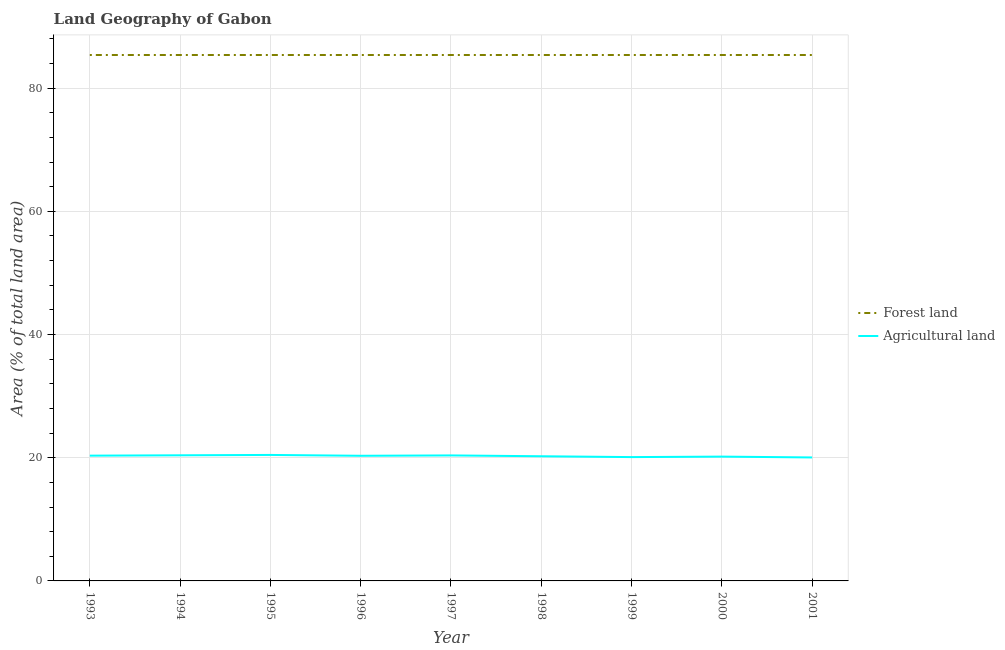Is the number of lines equal to the number of legend labels?
Give a very brief answer. Yes. What is the percentage of land area under forests in 1993?
Provide a succinct answer. 85.38. Across all years, what is the maximum percentage of land area under forests?
Your response must be concise. 85.38. Across all years, what is the minimum percentage of land area under forests?
Your response must be concise. 85.38. In which year was the percentage of land area under agriculture maximum?
Keep it short and to the point. 1995. In which year was the percentage of land area under forests minimum?
Offer a terse response. 1993. What is the total percentage of land area under agriculture in the graph?
Provide a succinct answer. 182.44. What is the difference between the percentage of land area under forests in 1995 and the percentage of land area under agriculture in 2001?
Your response must be concise. 65.34. What is the average percentage of land area under agriculture per year?
Make the answer very short. 20.27. In the year 1999, what is the difference between the percentage of land area under agriculture and percentage of land area under forests?
Offer a terse response. -65.28. What is the difference between the highest and the second highest percentage of land area under agriculture?
Ensure brevity in your answer.  0.06. What is the difference between the highest and the lowest percentage of land area under forests?
Provide a succinct answer. 0. In how many years, is the percentage of land area under agriculture greater than the average percentage of land area under agriculture taken over all years?
Your response must be concise. 5. Is the percentage of land area under agriculture strictly greater than the percentage of land area under forests over the years?
Give a very brief answer. No. What is the difference between two consecutive major ticks on the Y-axis?
Offer a very short reply. 20. Are the values on the major ticks of Y-axis written in scientific E-notation?
Provide a short and direct response. No. Does the graph contain any zero values?
Offer a terse response. No. Does the graph contain grids?
Keep it short and to the point. Yes. What is the title of the graph?
Your answer should be very brief. Land Geography of Gabon. What is the label or title of the Y-axis?
Keep it short and to the point. Area (% of total land area). What is the Area (% of total land area) of Forest land in 1993?
Your response must be concise. 85.38. What is the Area (% of total land area) of Agricultural land in 1993?
Your response must be concise. 20.34. What is the Area (% of total land area) of Forest land in 1994?
Your answer should be compact. 85.38. What is the Area (% of total land area) in Agricultural land in 1994?
Provide a short and direct response. 20.39. What is the Area (% of total land area) of Forest land in 1995?
Offer a terse response. 85.38. What is the Area (% of total land area) in Agricultural land in 1995?
Provide a short and direct response. 20.45. What is the Area (% of total land area) of Forest land in 1996?
Keep it short and to the point. 85.38. What is the Area (% of total land area) in Agricultural land in 1996?
Your answer should be very brief. 20.32. What is the Area (% of total land area) in Forest land in 1997?
Give a very brief answer. 85.38. What is the Area (% of total land area) of Agricultural land in 1997?
Your response must be concise. 20.37. What is the Area (% of total land area) of Forest land in 1998?
Provide a short and direct response. 85.38. What is the Area (% of total land area) in Agricultural land in 1998?
Your answer should be compact. 20.24. What is the Area (% of total land area) in Forest land in 1999?
Keep it short and to the point. 85.38. What is the Area (% of total land area) of Agricultural land in 1999?
Offer a very short reply. 20.1. What is the Area (% of total land area) of Forest land in 2000?
Keep it short and to the point. 85.38. What is the Area (% of total land area) in Agricultural land in 2000?
Your answer should be compact. 20.18. What is the Area (% of total land area) in Forest land in 2001?
Give a very brief answer. 85.38. What is the Area (% of total land area) of Agricultural land in 2001?
Give a very brief answer. 20.05. Across all years, what is the maximum Area (% of total land area) of Forest land?
Provide a succinct answer. 85.38. Across all years, what is the maximum Area (% of total land area) of Agricultural land?
Provide a succinct answer. 20.45. Across all years, what is the minimum Area (% of total land area) in Forest land?
Your answer should be very brief. 85.38. Across all years, what is the minimum Area (% of total land area) in Agricultural land?
Your response must be concise. 20.05. What is the total Area (% of total land area) of Forest land in the graph?
Your response must be concise. 768.42. What is the total Area (% of total land area) of Agricultural land in the graph?
Your answer should be compact. 182.44. What is the difference between the Area (% of total land area) in Forest land in 1993 and that in 1994?
Your response must be concise. 0. What is the difference between the Area (% of total land area) in Agricultural land in 1993 and that in 1994?
Provide a short and direct response. -0.06. What is the difference between the Area (% of total land area) of Forest land in 1993 and that in 1995?
Provide a short and direct response. 0. What is the difference between the Area (% of total land area) of Agricultural land in 1993 and that in 1995?
Your answer should be compact. -0.12. What is the difference between the Area (% of total land area) of Agricultural land in 1993 and that in 1996?
Offer a very short reply. 0.02. What is the difference between the Area (% of total land area) of Forest land in 1993 and that in 1997?
Keep it short and to the point. 0. What is the difference between the Area (% of total land area) in Agricultural land in 1993 and that in 1997?
Ensure brevity in your answer.  -0.04. What is the difference between the Area (% of total land area) of Agricultural land in 1993 and that in 1998?
Ensure brevity in your answer.  0.1. What is the difference between the Area (% of total land area) of Forest land in 1993 and that in 1999?
Offer a very short reply. 0. What is the difference between the Area (% of total land area) of Agricultural land in 1993 and that in 1999?
Your answer should be compact. 0.23. What is the difference between the Area (% of total land area) in Forest land in 1993 and that in 2000?
Offer a very short reply. 0. What is the difference between the Area (% of total land area) in Agricultural land in 1993 and that in 2000?
Make the answer very short. 0.16. What is the difference between the Area (% of total land area) of Forest land in 1993 and that in 2001?
Your answer should be compact. 0. What is the difference between the Area (% of total land area) in Agricultural land in 1993 and that in 2001?
Offer a terse response. 0.29. What is the difference between the Area (% of total land area) in Forest land in 1994 and that in 1995?
Provide a short and direct response. 0. What is the difference between the Area (% of total land area) in Agricultural land in 1994 and that in 1995?
Give a very brief answer. -0.06. What is the difference between the Area (% of total land area) of Agricultural land in 1994 and that in 1996?
Your response must be concise. 0.08. What is the difference between the Area (% of total land area) in Forest land in 1994 and that in 1997?
Make the answer very short. 0. What is the difference between the Area (% of total land area) of Agricultural land in 1994 and that in 1997?
Give a very brief answer. 0.02. What is the difference between the Area (% of total land area) of Agricultural land in 1994 and that in 1998?
Give a very brief answer. 0.16. What is the difference between the Area (% of total land area) of Agricultural land in 1994 and that in 1999?
Provide a succinct answer. 0.29. What is the difference between the Area (% of total land area) of Forest land in 1994 and that in 2000?
Make the answer very short. 0. What is the difference between the Area (% of total land area) in Agricultural land in 1994 and that in 2000?
Your response must be concise. 0.21. What is the difference between the Area (% of total land area) of Agricultural land in 1994 and that in 2001?
Offer a very short reply. 0.35. What is the difference between the Area (% of total land area) of Forest land in 1995 and that in 1996?
Your answer should be compact. 0. What is the difference between the Area (% of total land area) in Agricultural land in 1995 and that in 1996?
Keep it short and to the point. 0.14. What is the difference between the Area (% of total land area) in Forest land in 1995 and that in 1997?
Offer a very short reply. 0. What is the difference between the Area (% of total land area) in Agricultural land in 1995 and that in 1997?
Offer a very short reply. 0.08. What is the difference between the Area (% of total land area) in Agricultural land in 1995 and that in 1998?
Offer a very short reply. 0.21. What is the difference between the Area (% of total land area) of Forest land in 1995 and that in 1999?
Provide a short and direct response. 0. What is the difference between the Area (% of total land area) of Agricultural land in 1995 and that in 1999?
Your answer should be compact. 0.35. What is the difference between the Area (% of total land area) in Agricultural land in 1995 and that in 2000?
Your answer should be very brief. 0.27. What is the difference between the Area (% of total land area) in Agricultural land in 1995 and that in 2001?
Your answer should be very brief. 0.41. What is the difference between the Area (% of total land area) in Agricultural land in 1996 and that in 1997?
Offer a very short reply. -0.06. What is the difference between the Area (% of total land area) in Forest land in 1996 and that in 1998?
Keep it short and to the point. 0. What is the difference between the Area (% of total land area) in Agricultural land in 1996 and that in 1998?
Offer a terse response. 0.08. What is the difference between the Area (% of total land area) of Forest land in 1996 and that in 1999?
Provide a succinct answer. 0. What is the difference between the Area (% of total land area) in Agricultural land in 1996 and that in 1999?
Your answer should be compact. 0.21. What is the difference between the Area (% of total land area) of Forest land in 1996 and that in 2000?
Provide a succinct answer. 0. What is the difference between the Area (% of total land area) of Agricultural land in 1996 and that in 2000?
Keep it short and to the point. 0.14. What is the difference between the Area (% of total land area) in Agricultural land in 1996 and that in 2001?
Your answer should be compact. 0.27. What is the difference between the Area (% of total land area) in Agricultural land in 1997 and that in 1998?
Make the answer very short. 0.14. What is the difference between the Area (% of total land area) in Forest land in 1997 and that in 1999?
Keep it short and to the point. 0. What is the difference between the Area (% of total land area) in Agricultural land in 1997 and that in 1999?
Your answer should be very brief. 0.27. What is the difference between the Area (% of total land area) of Agricultural land in 1997 and that in 2000?
Your response must be concise. 0.19. What is the difference between the Area (% of total land area) in Agricultural land in 1997 and that in 2001?
Offer a terse response. 0.33. What is the difference between the Area (% of total land area) in Agricultural land in 1998 and that in 1999?
Give a very brief answer. 0.14. What is the difference between the Area (% of total land area) of Forest land in 1998 and that in 2000?
Your answer should be very brief. 0. What is the difference between the Area (% of total land area) in Agricultural land in 1998 and that in 2000?
Provide a succinct answer. 0.06. What is the difference between the Area (% of total land area) of Forest land in 1998 and that in 2001?
Make the answer very short. 0. What is the difference between the Area (% of total land area) in Agricultural land in 1998 and that in 2001?
Ensure brevity in your answer.  0.19. What is the difference between the Area (% of total land area) in Forest land in 1999 and that in 2000?
Make the answer very short. 0. What is the difference between the Area (% of total land area) in Agricultural land in 1999 and that in 2000?
Give a very brief answer. -0.08. What is the difference between the Area (% of total land area) in Forest land in 1999 and that in 2001?
Your answer should be compact. 0. What is the difference between the Area (% of total land area) of Agricultural land in 1999 and that in 2001?
Your response must be concise. 0.06. What is the difference between the Area (% of total land area) in Agricultural land in 2000 and that in 2001?
Your answer should be very brief. 0.14. What is the difference between the Area (% of total land area) in Forest land in 1993 and the Area (% of total land area) in Agricultural land in 1994?
Ensure brevity in your answer.  64.99. What is the difference between the Area (% of total land area) in Forest land in 1993 and the Area (% of total land area) in Agricultural land in 1995?
Your response must be concise. 64.93. What is the difference between the Area (% of total land area) of Forest land in 1993 and the Area (% of total land area) of Agricultural land in 1996?
Your answer should be compact. 65.06. What is the difference between the Area (% of total land area) of Forest land in 1993 and the Area (% of total land area) of Agricultural land in 1997?
Your answer should be very brief. 65.01. What is the difference between the Area (% of total land area) of Forest land in 1993 and the Area (% of total land area) of Agricultural land in 1998?
Ensure brevity in your answer.  65.14. What is the difference between the Area (% of total land area) in Forest land in 1993 and the Area (% of total land area) in Agricultural land in 1999?
Offer a very short reply. 65.28. What is the difference between the Area (% of total land area) of Forest land in 1993 and the Area (% of total land area) of Agricultural land in 2000?
Keep it short and to the point. 65.2. What is the difference between the Area (% of total land area) of Forest land in 1993 and the Area (% of total land area) of Agricultural land in 2001?
Your response must be concise. 65.34. What is the difference between the Area (% of total land area) in Forest land in 1994 and the Area (% of total land area) in Agricultural land in 1995?
Your response must be concise. 64.93. What is the difference between the Area (% of total land area) of Forest land in 1994 and the Area (% of total land area) of Agricultural land in 1996?
Your answer should be compact. 65.06. What is the difference between the Area (% of total land area) of Forest land in 1994 and the Area (% of total land area) of Agricultural land in 1997?
Offer a very short reply. 65.01. What is the difference between the Area (% of total land area) of Forest land in 1994 and the Area (% of total land area) of Agricultural land in 1998?
Your answer should be compact. 65.14. What is the difference between the Area (% of total land area) of Forest land in 1994 and the Area (% of total land area) of Agricultural land in 1999?
Provide a succinct answer. 65.28. What is the difference between the Area (% of total land area) of Forest land in 1994 and the Area (% of total land area) of Agricultural land in 2000?
Your response must be concise. 65.2. What is the difference between the Area (% of total land area) in Forest land in 1994 and the Area (% of total land area) in Agricultural land in 2001?
Keep it short and to the point. 65.34. What is the difference between the Area (% of total land area) of Forest land in 1995 and the Area (% of total land area) of Agricultural land in 1996?
Give a very brief answer. 65.06. What is the difference between the Area (% of total land area) in Forest land in 1995 and the Area (% of total land area) in Agricultural land in 1997?
Your answer should be compact. 65.01. What is the difference between the Area (% of total land area) of Forest land in 1995 and the Area (% of total land area) of Agricultural land in 1998?
Keep it short and to the point. 65.14. What is the difference between the Area (% of total land area) of Forest land in 1995 and the Area (% of total land area) of Agricultural land in 1999?
Your answer should be compact. 65.28. What is the difference between the Area (% of total land area) of Forest land in 1995 and the Area (% of total land area) of Agricultural land in 2000?
Give a very brief answer. 65.2. What is the difference between the Area (% of total land area) in Forest land in 1995 and the Area (% of total land area) in Agricultural land in 2001?
Ensure brevity in your answer.  65.34. What is the difference between the Area (% of total land area) in Forest land in 1996 and the Area (% of total land area) in Agricultural land in 1997?
Provide a short and direct response. 65.01. What is the difference between the Area (% of total land area) of Forest land in 1996 and the Area (% of total land area) of Agricultural land in 1998?
Offer a terse response. 65.14. What is the difference between the Area (% of total land area) in Forest land in 1996 and the Area (% of total land area) in Agricultural land in 1999?
Your answer should be compact. 65.28. What is the difference between the Area (% of total land area) of Forest land in 1996 and the Area (% of total land area) of Agricultural land in 2000?
Your answer should be very brief. 65.2. What is the difference between the Area (% of total land area) of Forest land in 1996 and the Area (% of total land area) of Agricultural land in 2001?
Your answer should be compact. 65.34. What is the difference between the Area (% of total land area) in Forest land in 1997 and the Area (% of total land area) in Agricultural land in 1998?
Provide a short and direct response. 65.14. What is the difference between the Area (% of total land area) in Forest land in 1997 and the Area (% of total land area) in Agricultural land in 1999?
Give a very brief answer. 65.28. What is the difference between the Area (% of total land area) of Forest land in 1997 and the Area (% of total land area) of Agricultural land in 2000?
Ensure brevity in your answer.  65.2. What is the difference between the Area (% of total land area) of Forest land in 1997 and the Area (% of total land area) of Agricultural land in 2001?
Your response must be concise. 65.34. What is the difference between the Area (% of total land area) in Forest land in 1998 and the Area (% of total land area) in Agricultural land in 1999?
Provide a short and direct response. 65.28. What is the difference between the Area (% of total land area) in Forest land in 1998 and the Area (% of total land area) in Agricultural land in 2000?
Offer a very short reply. 65.2. What is the difference between the Area (% of total land area) in Forest land in 1998 and the Area (% of total land area) in Agricultural land in 2001?
Offer a very short reply. 65.34. What is the difference between the Area (% of total land area) in Forest land in 1999 and the Area (% of total land area) in Agricultural land in 2000?
Keep it short and to the point. 65.2. What is the difference between the Area (% of total land area) of Forest land in 1999 and the Area (% of total land area) of Agricultural land in 2001?
Keep it short and to the point. 65.34. What is the difference between the Area (% of total land area) in Forest land in 2000 and the Area (% of total land area) in Agricultural land in 2001?
Your answer should be compact. 65.34. What is the average Area (% of total land area) of Forest land per year?
Offer a very short reply. 85.38. What is the average Area (% of total land area) in Agricultural land per year?
Make the answer very short. 20.27. In the year 1993, what is the difference between the Area (% of total land area) in Forest land and Area (% of total land area) in Agricultural land?
Offer a terse response. 65.04. In the year 1994, what is the difference between the Area (% of total land area) of Forest land and Area (% of total land area) of Agricultural land?
Your answer should be compact. 64.99. In the year 1995, what is the difference between the Area (% of total land area) in Forest land and Area (% of total land area) in Agricultural land?
Keep it short and to the point. 64.93. In the year 1996, what is the difference between the Area (% of total land area) in Forest land and Area (% of total land area) in Agricultural land?
Provide a succinct answer. 65.06. In the year 1997, what is the difference between the Area (% of total land area) in Forest land and Area (% of total land area) in Agricultural land?
Give a very brief answer. 65.01. In the year 1998, what is the difference between the Area (% of total land area) in Forest land and Area (% of total land area) in Agricultural land?
Keep it short and to the point. 65.14. In the year 1999, what is the difference between the Area (% of total land area) in Forest land and Area (% of total land area) in Agricultural land?
Your answer should be compact. 65.28. In the year 2000, what is the difference between the Area (% of total land area) in Forest land and Area (% of total land area) in Agricultural land?
Make the answer very short. 65.2. In the year 2001, what is the difference between the Area (% of total land area) in Forest land and Area (% of total land area) in Agricultural land?
Your answer should be very brief. 65.34. What is the ratio of the Area (% of total land area) in Forest land in 1993 to that in 1994?
Give a very brief answer. 1. What is the ratio of the Area (% of total land area) in Forest land in 1993 to that in 1995?
Provide a succinct answer. 1. What is the ratio of the Area (% of total land area) in Agricultural land in 1993 to that in 1995?
Provide a short and direct response. 0.99. What is the ratio of the Area (% of total land area) of Forest land in 1993 to that in 1996?
Keep it short and to the point. 1. What is the ratio of the Area (% of total land area) of Forest land in 1993 to that in 1997?
Give a very brief answer. 1. What is the ratio of the Area (% of total land area) in Agricultural land in 1993 to that in 1998?
Make the answer very short. 1. What is the ratio of the Area (% of total land area) in Forest land in 1993 to that in 1999?
Ensure brevity in your answer.  1. What is the ratio of the Area (% of total land area) of Agricultural land in 1993 to that in 1999?
Offer a terse response. 1.01. What is the ratio of the Area (% of total land area) of Agricultural land in 1993 to that in 2000?
Give a very brief answer. 1.01. What is the ratio of the Area (% of total land area) of Forest land in 1993 to that in 2001?
Provide a short and direct response. 1. What is the ratio of the Area (% of total land area) of Agricultural land in 1993 to that in 2001?
Ensure brevity in your answer.  1.01. What is the ratio of the Area (% of total land area) in Agricultural land in 1994 to that in 1995?
Your response must be concise. 1. What is the ratio of the Area (% of total land area) in Forest land in 1994 to that in 1997?
Provide a succinct answer. 1. What is the ratio of the Area (% of total land area) in Agricultural land in 1994 to that in 1997?
Your response must be concise. 1. What is the ratio of the Area (% of total land area) of Agricultural land in 1994 to that in 1998?
Provide a short and direct response. 1.01. What is the ratio of the Area (% of total land area) in Agricultural land in 1994 to that in 1999?
Offer a terse response. 1.01. What is the ratio of the Area (% of total land area) of Agricultural land in 1994 to that in 2000?
Your answer should be very brief. 1.01. What is the ratio of the Area (% of total land area) of Forest land in 1994 to that in 2001?
Offer a terse response. 1. What is the ratio of the Area (% of total land area) in Agricultural land in 1994 to that in 2001?
Your answer should be very brief. 1.02. What is the ratio of the Area (% of total land area) of Forest land in 1995 to that in 1996?
Your answer should be compact. 1. What is the ratio of the Area (% of total land area) of Forest land in 1995 to that in 1997?
Offer a very short reply. 1. What is the ratio of the Area (% of total land area) in Agricultural land in 1995 to that in 1998?
Provide a succinct answer. 1.01. What is the ratio of the Area (% of total land area) in Forest land in 1995 to that in 1999?
Provide a succinct answer. 1. What is the ratio of the Area (% of total land area) in Agricultural land in 1995 to that in 1999?
Keep it short and to the point. 1.02. What is the ratio of the Area (% of total land area) of Forest land in 1995 to that in 2000?
Offer a very short reply. 1. What is the ratio of the Area (% of total land area) in Agricultural land in 1995 to that in 2000?
Make the answer very short. 1.01. What is the ratio of the Area (% of total land area) in Agricultural land in 1995 to that in 2001?
Keep it short and to the point. 1.02. What is the ratio of the Area (% of total land area) of Forest land in 1996 to that in 1997?
Your answer should be compact. 1. What is the ratio of the Area (% of total land area) in Forest land in 1996 to that in 1999?
Give a very brief answer. 1. What is the ratio of the Area (% of total land area) of Agricultural land in 1996 to that in 1999?
Make the answer very short. 1.01. What is the ratio of the Area (% of total land area) of Forest land in 1996 to that in 2000?
Your response must be concise. 1. What is the ratio of the Area (% of total land area) of Agricultural land in 1996 to that in 2001?
Provide a short and direct response. 1.01. What is the ratio of the Area (% of total land area) in Forest land in 1997 to that in 1998?
Provide a short and direct response. 1. What is the ratio of the Area (% of total land area) of Agricultural land in 1997 to that in 1999?
Your response must be concise. 1.01. What is the ratio of the Area (% of total land area) of Forest land in 1997 to that in 2000?
Make the answer very short. 1. What is the ratio of the Area (% of total land area) in Agricultural land in 1997 to that in 2000?
Your response must be concise. 1.01. What is the ratio of the Area (% of total land area) in Agricultural land in 1997 to that in 2001?
Provide a succinct answer. 1.02. What is the ratio of the Area (% of total land area) in Forest land in 1998 to that in 1999?
Ensure brevity in your answer.  1. What is the ratio of the Area (% of total land area) in Agricultural land in 1998 to that in 1999?
Ensure brevity in your answer.  1.01. What is the ratio of the Area (% of total land area) of Agricultural land in 1998 to that in 2000?
Give a very brief answer. 1. What is the ratio of the Area (% of total land area) in Agricultural land in 1998 to that in 2001?
Make the answer very short. 1.01. What is the ratio of the Area (% of total land area) in Forest land in 1999 to that in 2000?
Provide a succinct answer. 1. What is the ratio of the Area (% of total land area) in Agricultural land in 1999 to that in 2000?
Your answer should be compact. 1. What is the ratio of the Area (% of total land area) in Forest land in 1999 to that in 2001?
Offer a terse response. 1. What is the ratio of the Area (% of total land area) in Agricultural land in 2000 to that in 2001?
Give a very brief answer. 1.01. What is the difference between the highest and the second highest Area (% of total land area) in Forest land?
Keep it short and to the point. 0. What is the difference between the highest and the second highest Area (% of total land area) of Agricultural land?
Provide a short and direct response. 0.06. What is the difference between the highest and the lowest Area (% of total land area) of Forest land?
Provide a succinct answer. 0. What is the difference between the highest and the lowest Area (% of total land area) in Agricultural land?
Offer a terse response. 0.41. 